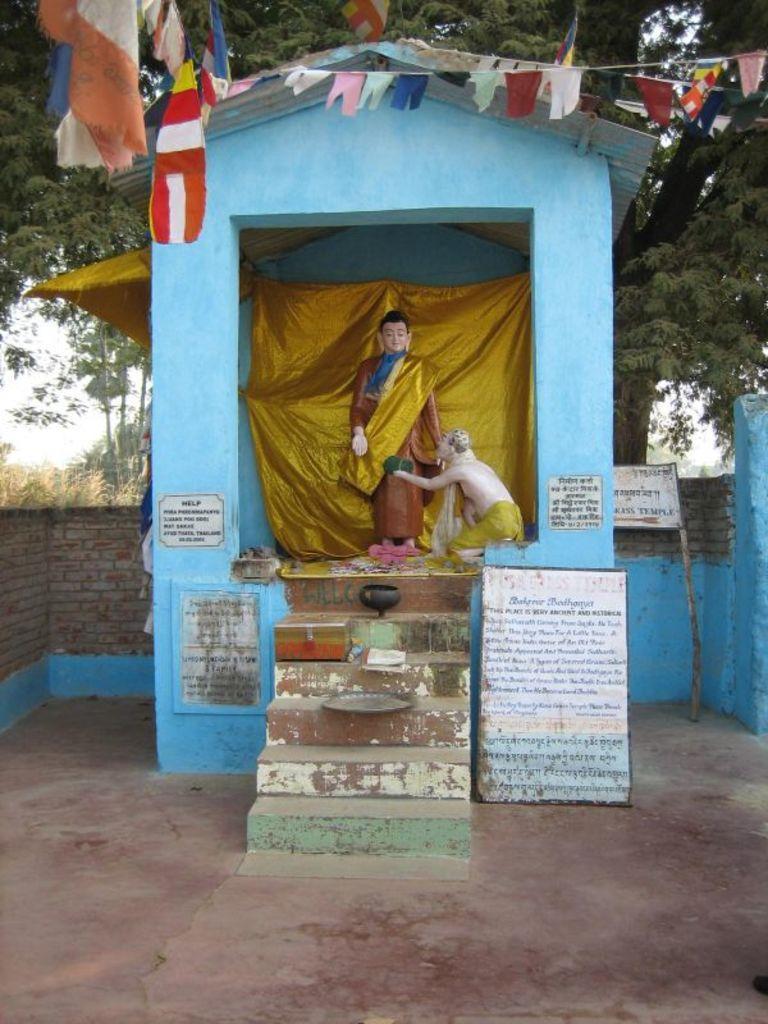In one or two sentences, can you explain what this image depicts? In the center of the image we can see house, statues, cloth, stairs, box book, plate, boards are there. In the background of the image we can see three, flags, sky, wall are there. At the bottom of the image there is a floor. 